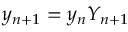<formula> <loc_0><loc_0><loc_500><loc_500>y _ { n + 1 } = y _ { n } Y _ { n + 1 }</formula> 